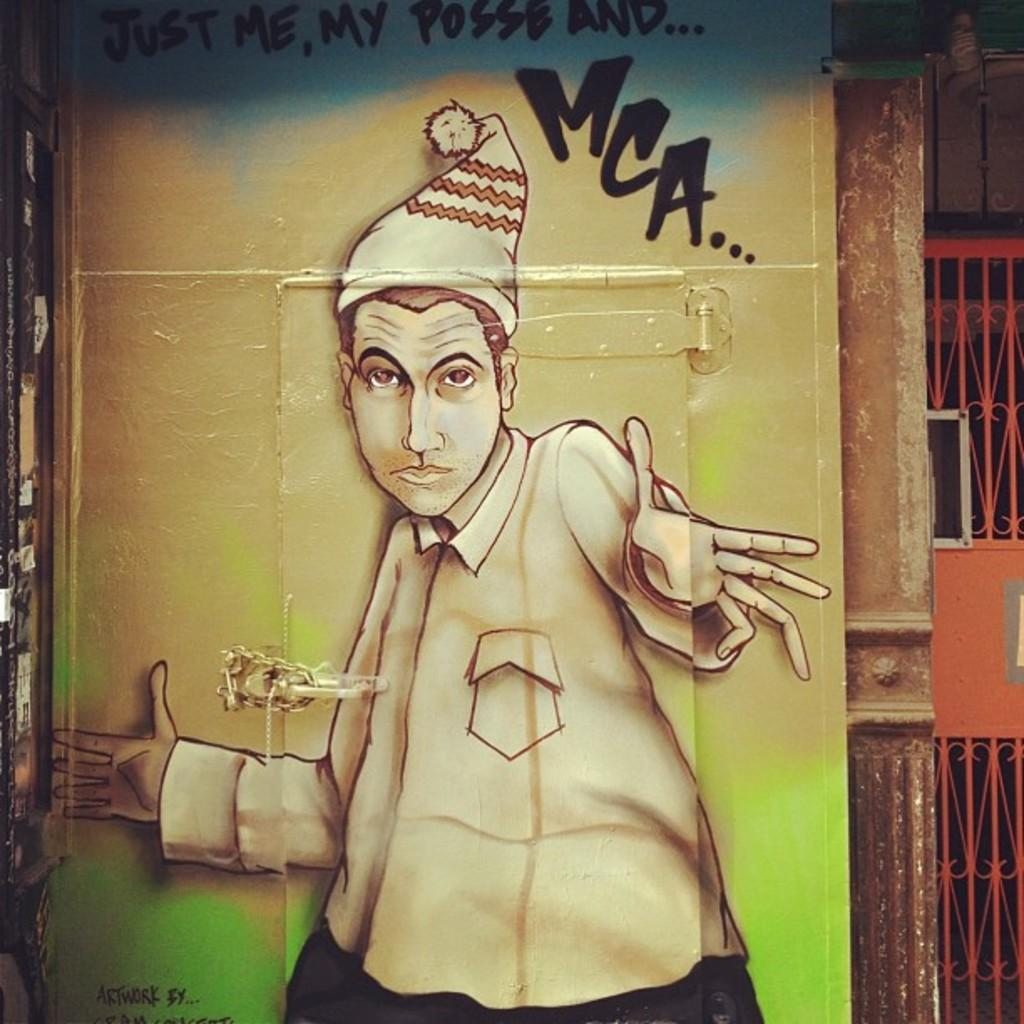What is the main subject of the image? The main subject of the image is a man with a cap. Where is the man located in the image? The man is depicted on a door. What else can be seen in the image besides the man? There is text in the image, as well as a pillar on the right side, and a gate. What type of behavior is the man exhibiting in the image during the winter season? The image does not provide information about the man's behavior or the season, as it only shows the man with a cap on a door. 